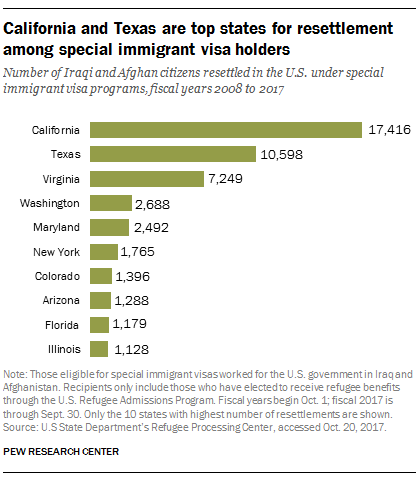Identify some key points in this picture. The value of the first longest bar in the graph is 17416. The difference between Florida and Illinois immigrant visa holders is unknown. 